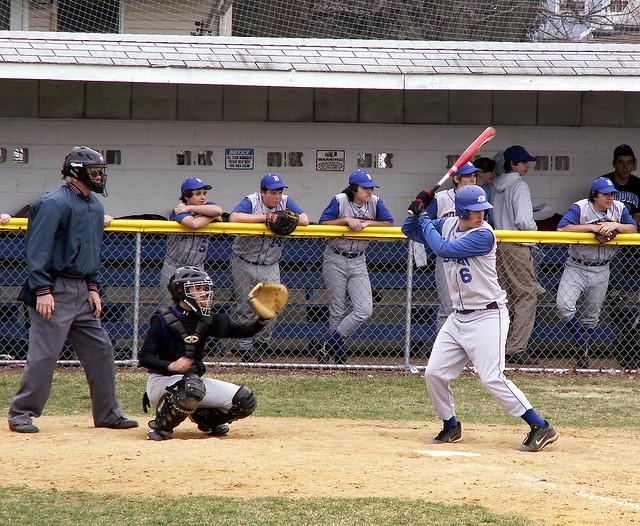What is the man wearing on his head?
Concise answer only. Helmet. What hand is the glove on the catcher?
Quick response, please. Left. What is the Jersey number of the hitter?
Write a very short answer. 6. 